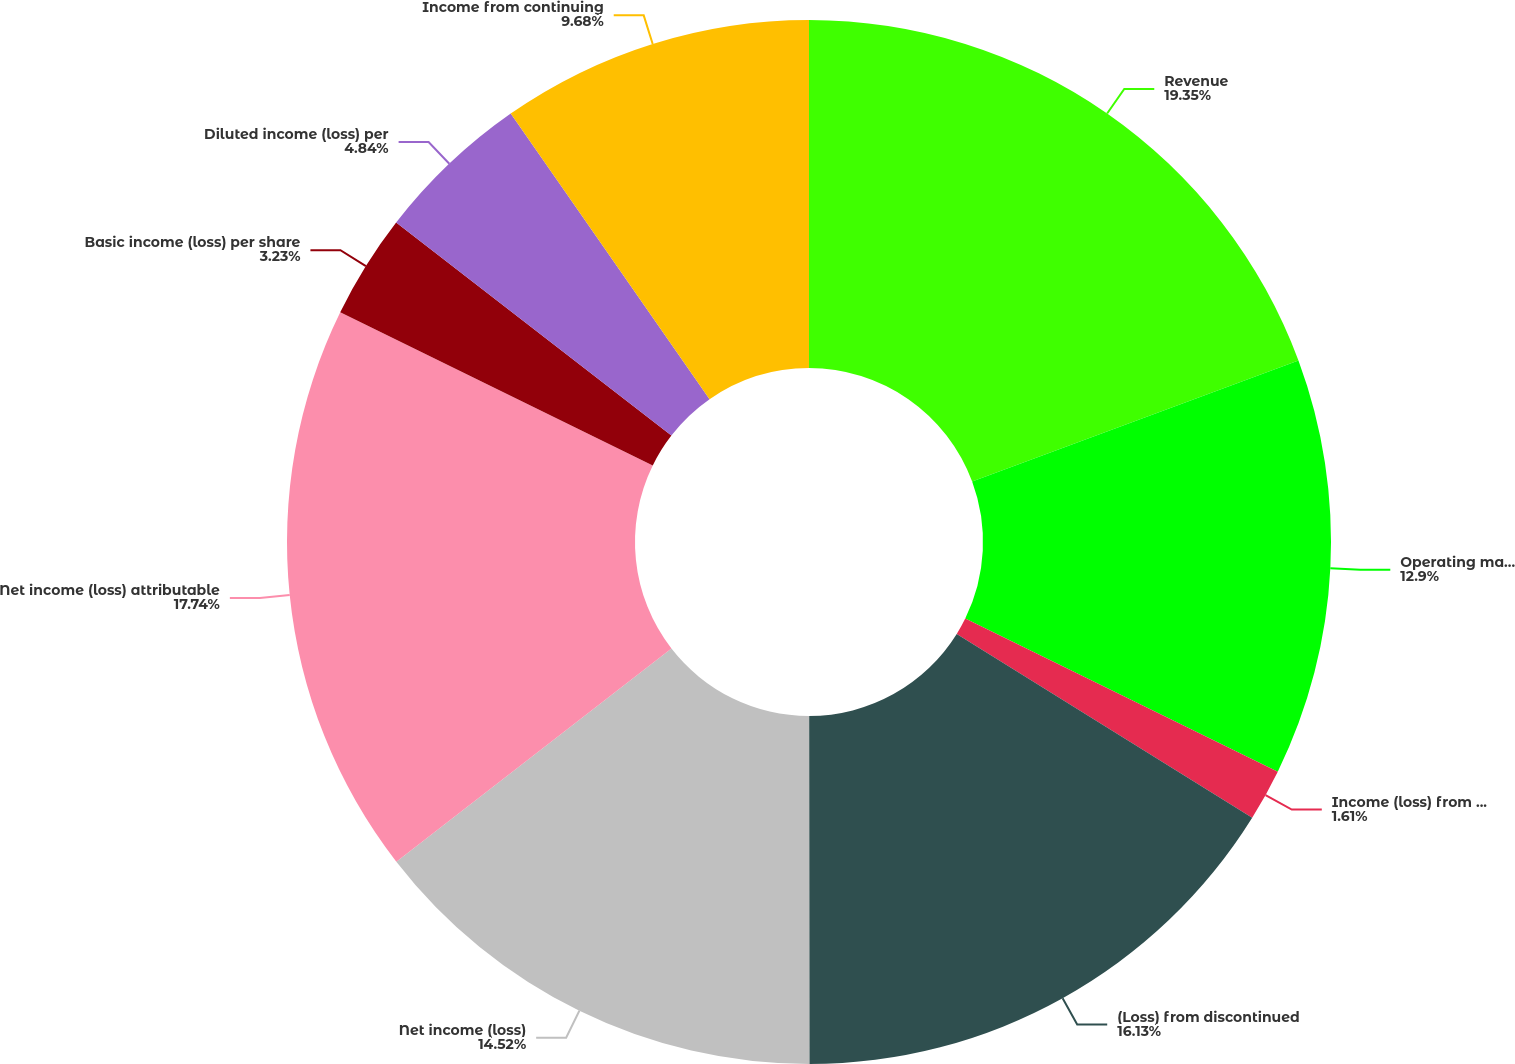Convert chart. <chart><loc_0><loc_0><loc_500><loc_500><pie_chart><fcel>Revenue<fcel>Operating margin<fcel>Income (loss) from continuing<fcel>(Loss) from discontinued<fcel>Net income (loss)<fcel>Net income (loss) attributable<fcel>Basic income (loss) per share<fcel>Diluted income (loss) per<fcel>Income from continuing<nl><fcel>19.35%<fcel>12.9%<fcel>1.61%<fcel>16.13%<fcel>14.52%<fcel>17.74%<fcel>3.23%<fcel>4.84%<fcel>9.68%<nl></chart> 